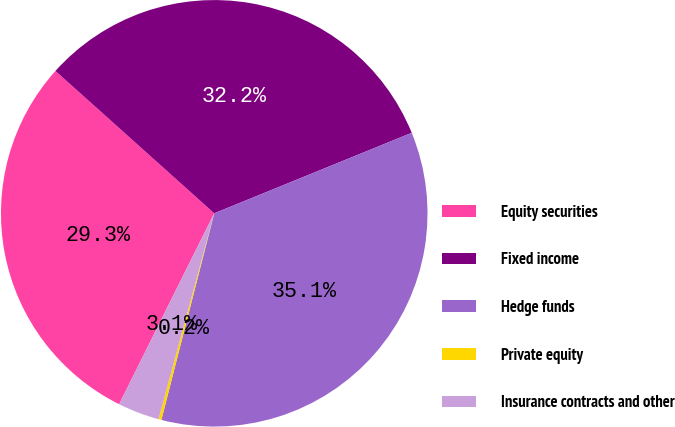Convert chart to OTSL. <chart><loc_0><loc_0><loc_500><loc_500><pie_chart><fcel>Equity securities<fcel>Fixed income<fcel>Hedge funds<fcel>Private equity<fcel>Insurance contracts and other<nl><fcel>29.28%<fcel>32.21%<fcel>35.15%<fcel>0.22%<fcel>3.15%<nl></chart> 